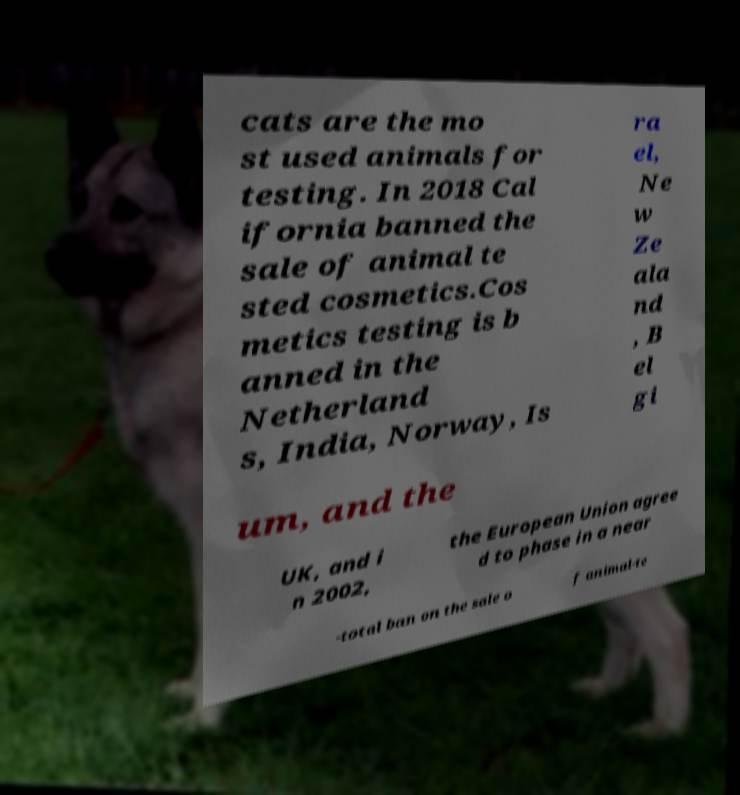Could you extract and type out the text from this image? cats are the mo st used animals for testing. In 2018 Cal ifornia banned the sale of animal te sted cosmetics.Cos metics testing is b anned in the Netherland s, India, Norway, Is ra el, Ne w Ze ala nd , B el gi um, and the UK, and i n 2002, the European Union agree d to phase in a near -total ban on the sale o f animal-te 